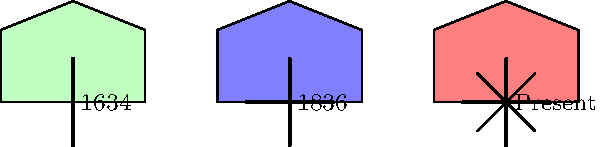Which element was added to Kidderminster's coat of arms in 1836 that distinguishes it from the 1634 version? To answer this question, let's analyze the evolution of Kidderminster's coat of arms as shown in the image:

1. 1634 version:
   - Simple shield design
   - Single vertical line in the center

2. 1836 version:
   - Shield design remains similar
   - Vertical line in the center is retained
   - A horizontal line is added, intersecting the vertical line

3. Present version:
   - Shield design remains consistent
   - Vertical and horizontal lines are retained
   - Additional diagonal crosses are added

The key difference between the 1634 and 1836 versions is the addition of the horizontal line in 1836. This horizontal line, intersecting with the existing vertical line, creates a cross shape on the shield.
Answer: Horizontal line 